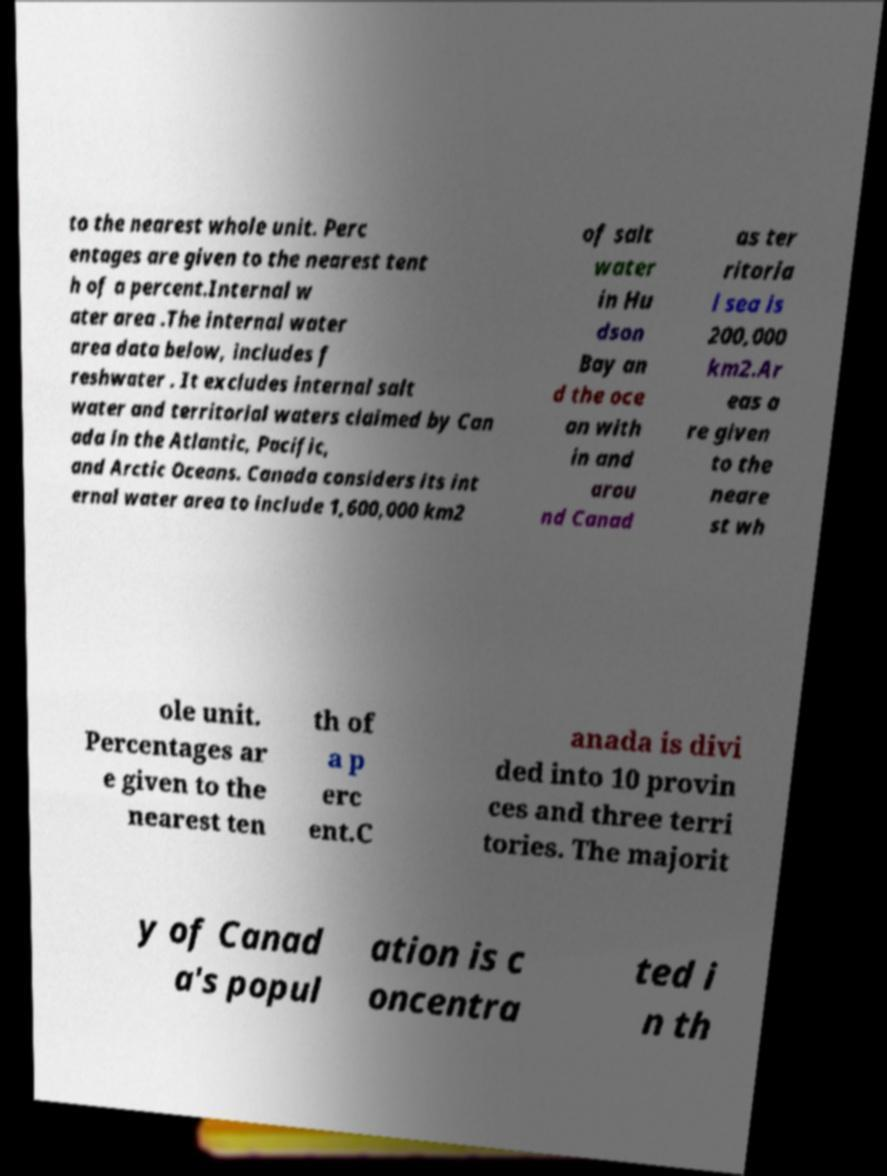Could you extract and type out the text from this image? to the nearest whole unit. Perc entages are given to the nearest tent h of a percent.Internal w ater area .The internal water area data below, includes f reshwater . It excludes internal salt water and territorial waters claimed by Can ada in the Atlantic, Pacific, and Arctic Oceans. Canada considers its int ernal water area to include 1,600,000 km2 of salt water in Hu dson Bay an d the oce an with in and arou nd Canad as ter ritoria l sea is 200,000 km2.Ar eas a re given to the neare st wh ole unit. Percentages ar e given to the nearest ten th of a p erc ent.C anada is divi ded into 10 provin ces and three terri tories. The majorit y of Canad a's popul ation is c oncentra ted i n th 